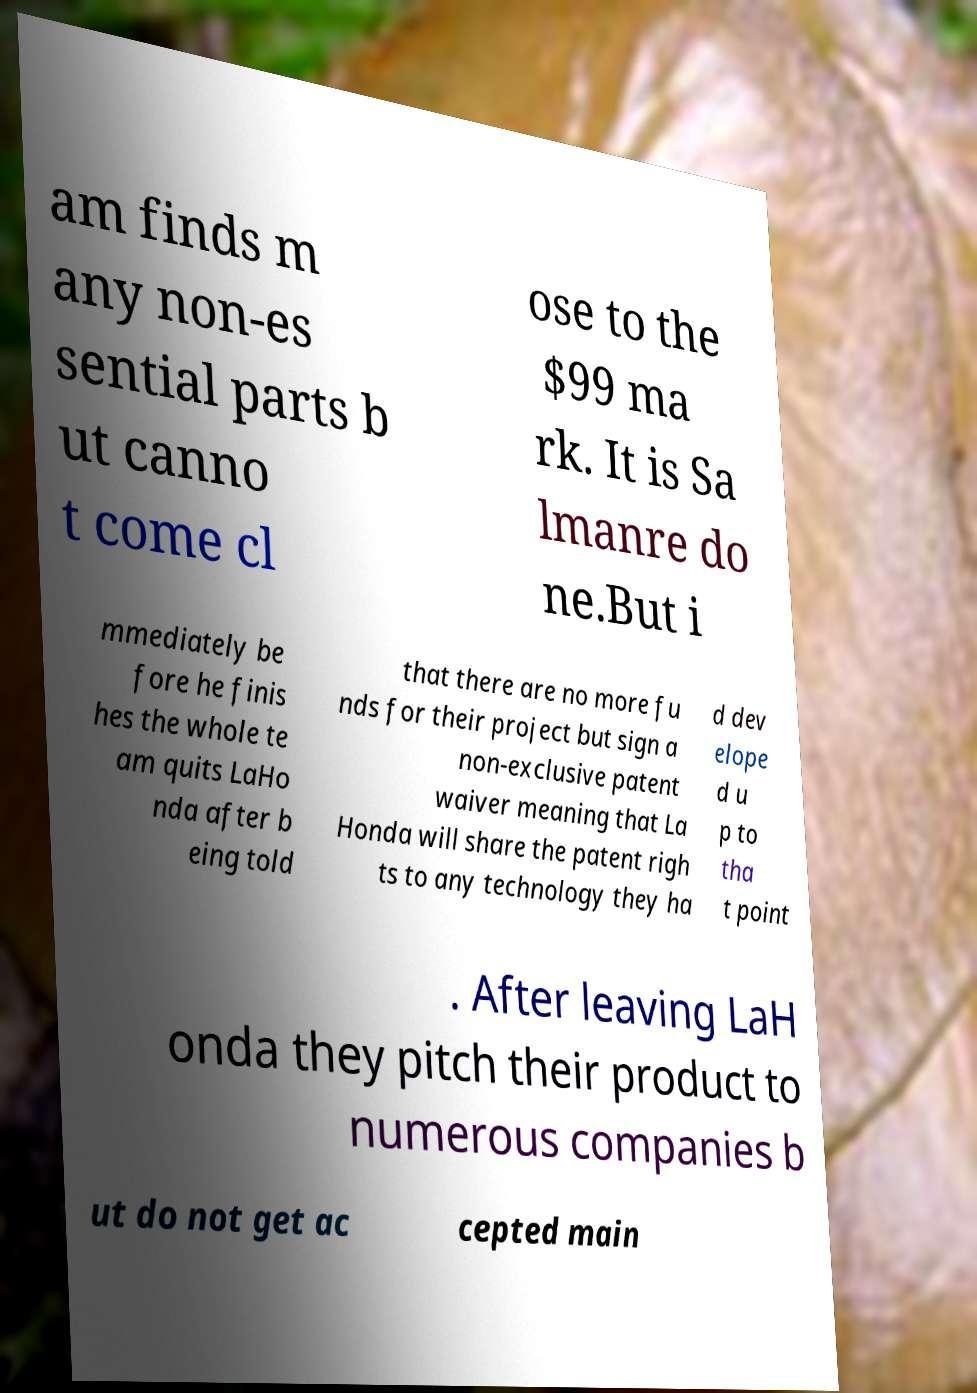For documentation purposes, I need the text within this image transcribed. Could you provide that? am finds m any non-es sential parts b ut canno t come cl ose to the $99 ma rk. It is Sa lmanre do ne.But i mmediately be fore he finis hes the whole te am quits LaHo nda after b eing told that there are no more fu nds for their project but sign a non-exclusive patent waiver meaning that La Honda will share the patent righ ts to any technology they ha d dev elope d u p to tha t point . After leaving LaH onda they pitch their product to numerous companies b ut do not get ac cepted main 